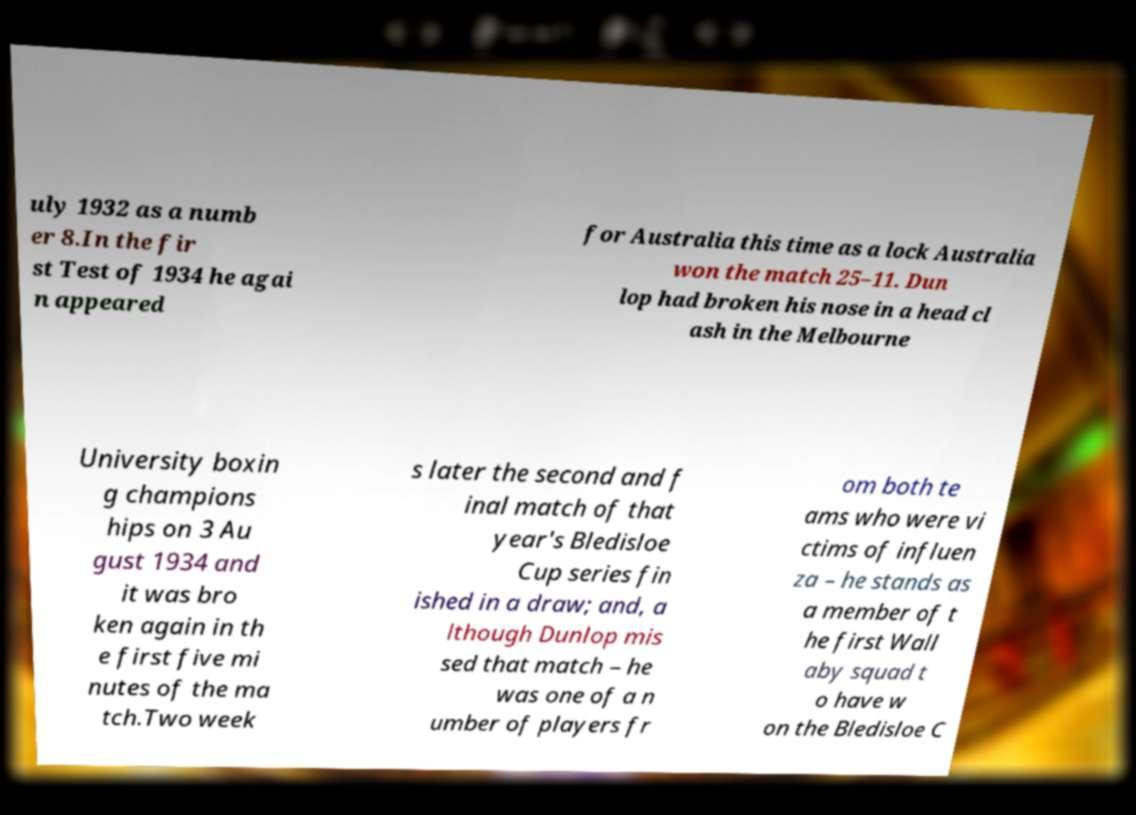Can you read and provide the text displayed in the image?This photo seems to have some interesting text. Can you extract and type it out for me? uly 1932 as a numb er 8.In the fir st Test of 1934 he agai n appeared for Australia this time as a lock Australia won the match 25–11. Dun lop had broken his nose in a head cl ash in the Melbourne University boxin g champions hips on 3 Au gust 1934 and it was bro ken again in th e first five mi nutes of the ma tch.Two week s later the second and f inal match of that year's Bledisloe Cup series fin ished in a draw; and, a lthough Dunlop mis sed that match – he was one of a n umber of players fr om both te ams who were vi ctims of influen za – he stands as a member of t he first Wall aby squad t o have w on the Bledisloe C 